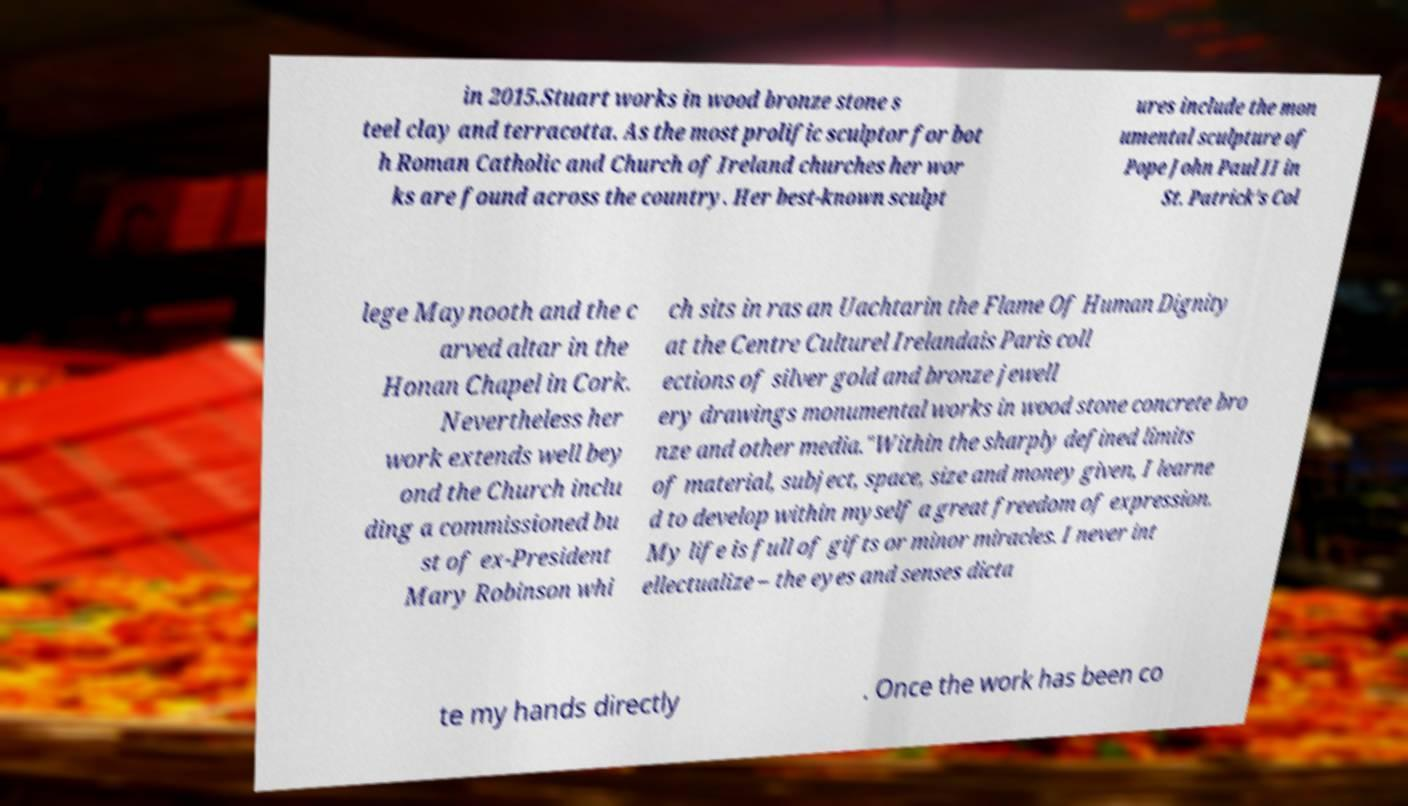For documentation purposes, I need the text within this image transcribed. Could you provide that? in 2015.Stuart works in wood bronze stone s teel clay and terracotta. As the most prolific sculptor for bot h Roman Catholic and Church of Ireland churches her wor ks are found across the country. Her best-known sculpt ures include the mon umental sculpture of Pope John Paul II in St. Patrick's Col lege Maynooth and the c arved altar in the Honan Chapel in Cork. Nevertheless her work extends well bey ond the Church inclu ding a commissioned bu st of ex-President Mary Robinson whi ch sits in ras an Uachtarin the Flame Of Human Dignity at the Centre Culturel Irelandais Paris coll ections of silver gold and bronze jewell ery drawings monumental works in wood stone concrete bro nze and other media."Within the sharply defined limits of material, subject, space, size and money given, I learne d to develop within myself a great freedom of expression. My life is full of gifts or minor miracles. I never int ellectualize – the eyes and senses dicta te my hands directly . Once the work has been co 